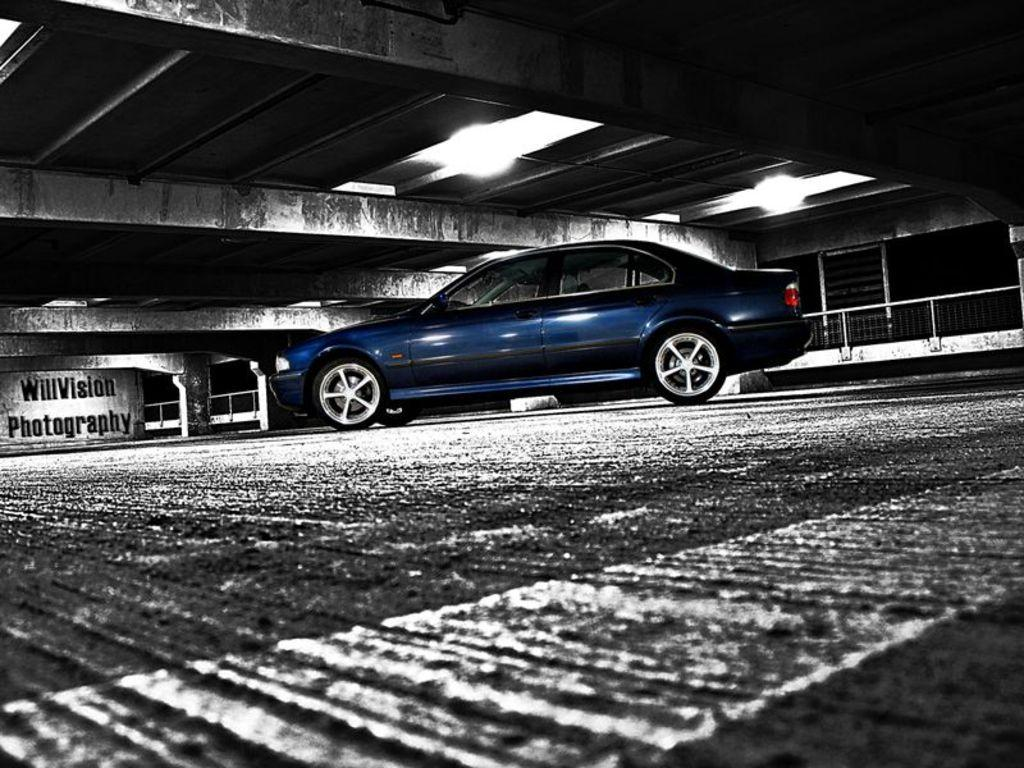What can be seen running through the image? There is a path in the image. What type of vehicle is present in the image? There is a blue color car in the image. Are there any words or letters visible in the image? Yes, there is writing in the image. What type of lighting is present in the image? There are lights on the ceiling in the image. Can you see a crow perched on the car in the image? There is no crow present in the image. What type of shock can be seen affecting the thumb in the image? There is no thumb or shock present in the image. 